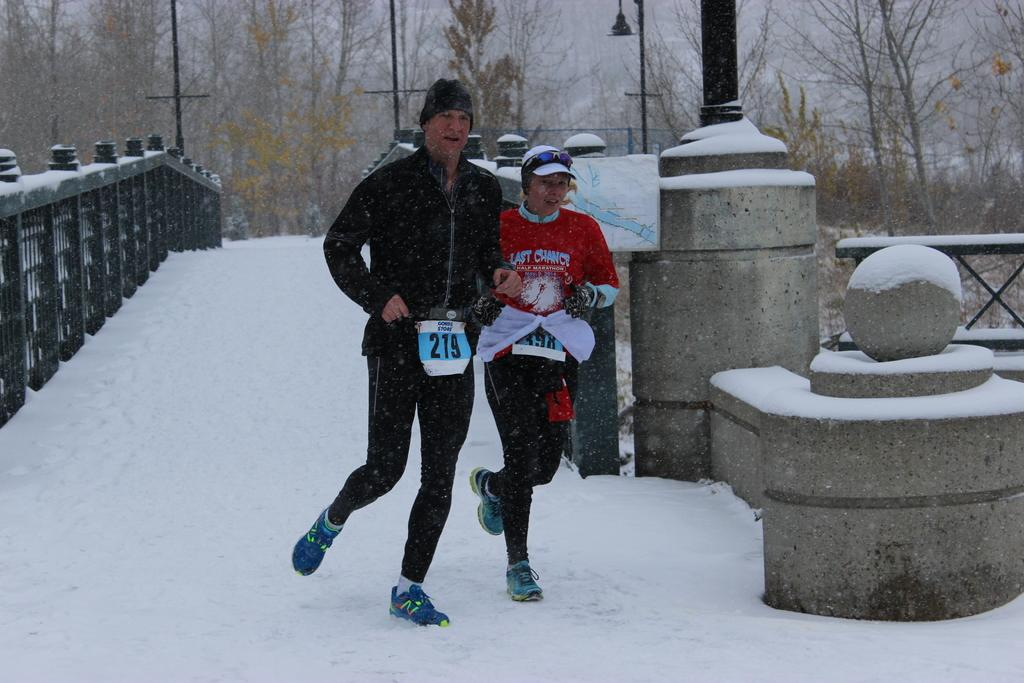<image>
Share a concise interpretation of the image provided. Man wearing a 219 sign running next to another woman in the snow. 